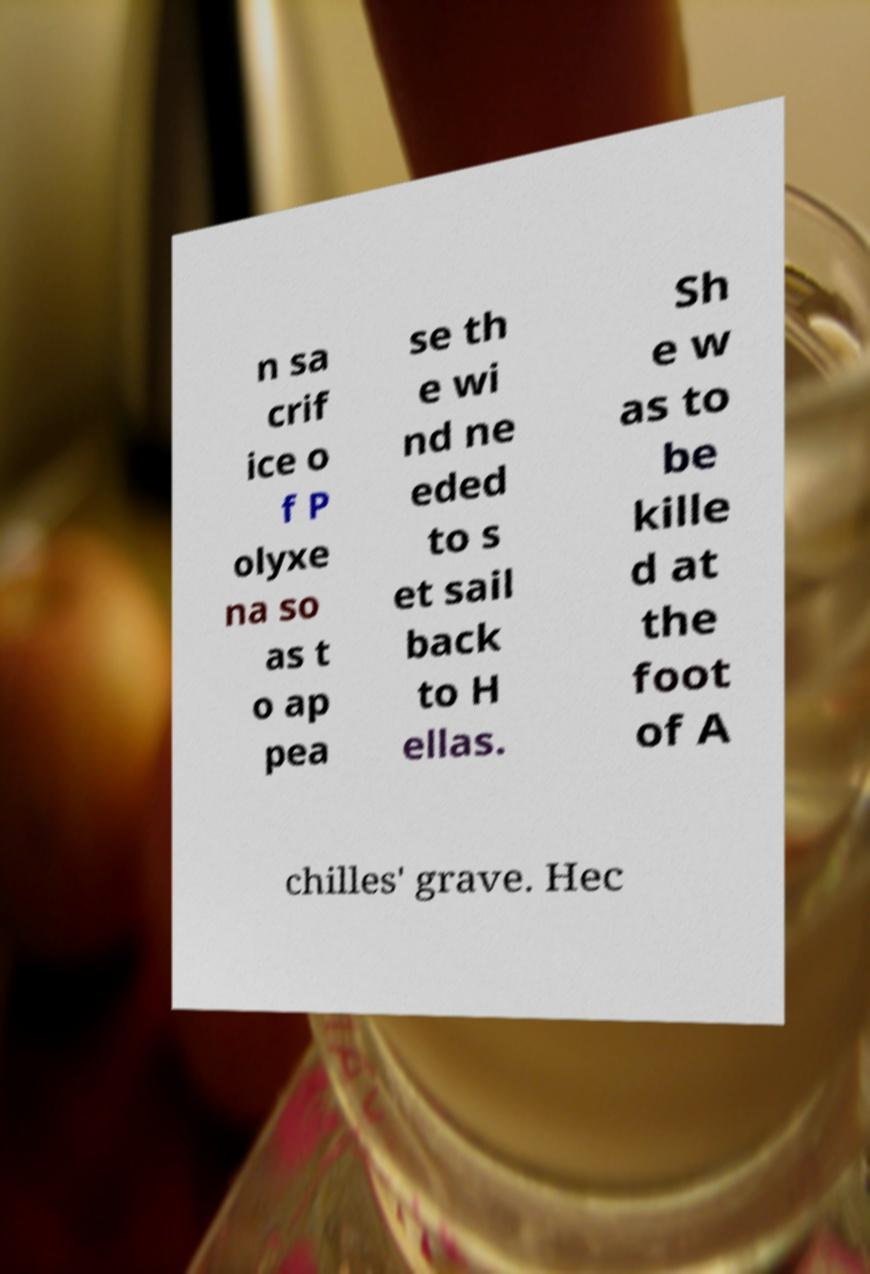Can you read and provide the text displayed in the image?This photo seems to have some interesting text. Can you extract and type it out for me? n sa crif ice o f P olyxe na so as t o ap pea se th e wi nd ne eded to s et sail back to H ellas. Sh e w as to be kille d at the foot of A chilles' grave. Hec 